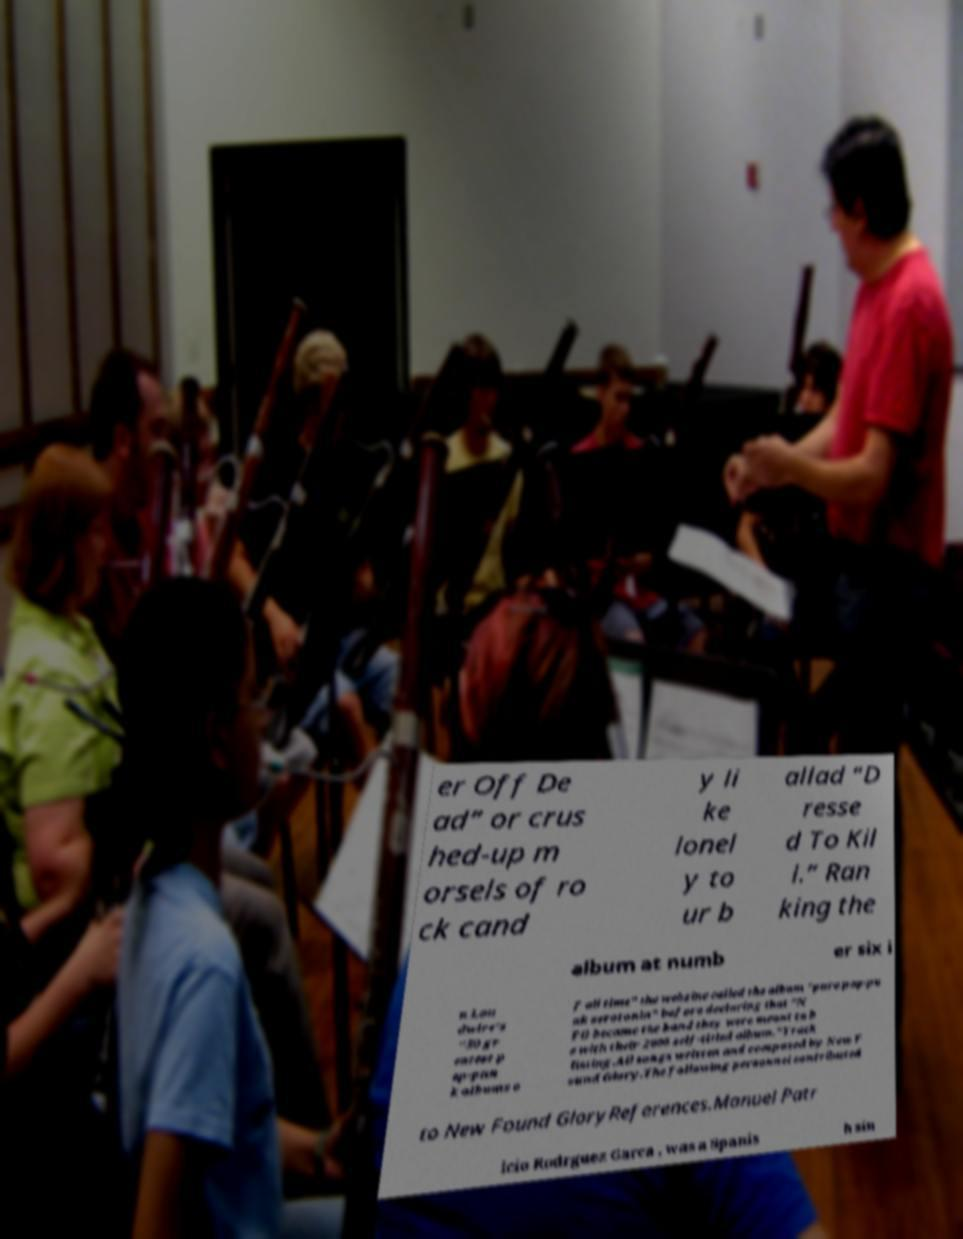What messages or text are displayed in this image? I need them in a readable, typed format. er Off De ad” or crus hed-up m orsels of ro ck cand y li ke lonel y to ur b allad “D resse d To Kil l.” Ran king the album at numb er six i n Lou dwire's "50 gr eatest p op-pun k albums o f all time" the webzine called the album "pure pop-pu nk serotonin" before declaring that "N FG became the band they were meant to b e with their 2000 self-titled album."Track listing.All songs written and composed by New F ound Glory.The following personnel contributed to New Found GloryReferences.Manuel Patr icio Rodrguez Garca , was a Spanis h sin 